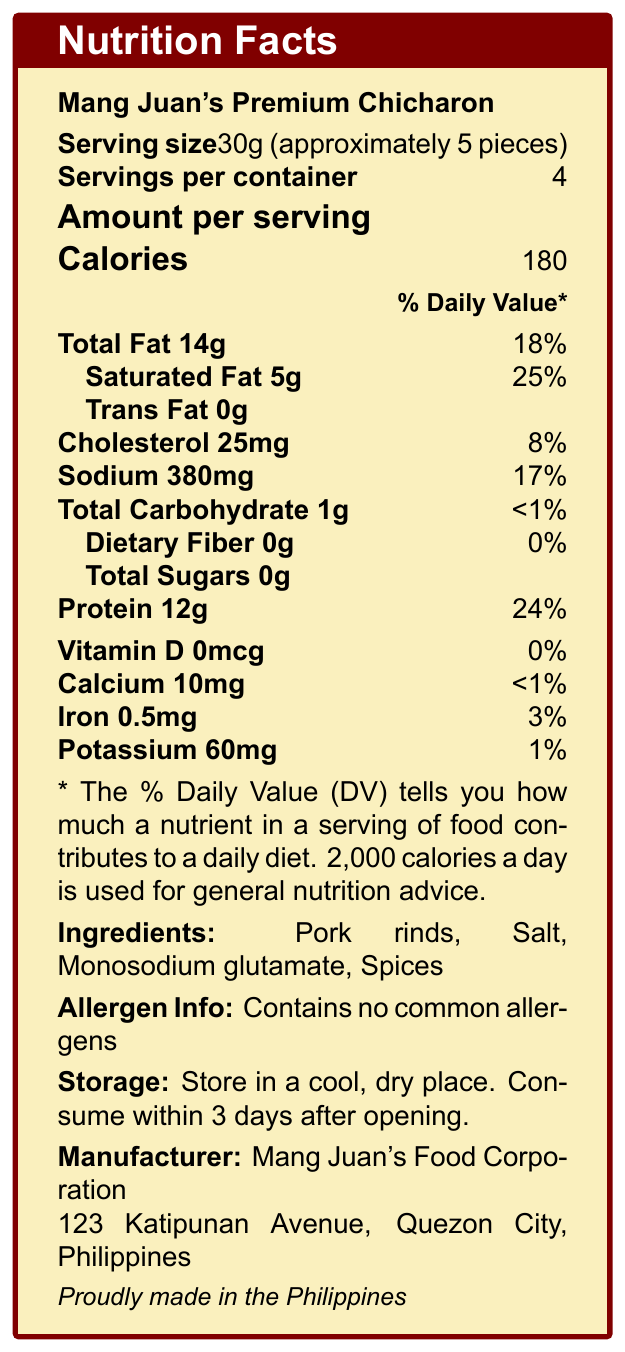what is the serving size of Mang Juan's Premium Chicharon? The serving size is specified in the document as 30g, which is approximately 5 pieces.
Answer: 30g (approximately 5 pieces) how many servings are there per container? The document states that the product has 4 servings per container.
Answer: 4 what is the amount of protein per serving? The amount of protein per serving is clearly indicated as 12g in the document.
Answer: 12g what percentage of the daily value of saturated fat does one serving contain? The document lists that one serving contains 25% of the daily value of saturated fat.
Answer: 25% what are the ingredients of Mang Juan's Premium Chicharon? The ingredients are listed in the document as Pork rinds, Salt, Monosodium glutamate, and Spices.
Answer: Pork rinds, Salt, Monosodium glutamate, Spices what is the total fat content per serving? According to the document, the total fat content per serving is 14g.
Answer: 14g how much sodium is in one serving? The document specifies that one serving contains 380mg of sodium.
Answer: 380mg how long should Mang Juan's Premium Chicharon be consumed after opening? The document advises consuming the product within 3 days after opening.
Answer: 3 days which of the following vitamins and minerals does Mang Juan's Premium Chicharon provide? A. Vitamin C B. Calcium C. Iron D. Vitamin D The document indicates that the product provides Iron (0.5mg), but Vitamin C, Calcium, and Vitamin D are either not provided or provided in very small amounts.
Answer: C. Iron what type of fat is minimally present in chicharon? A. Monounsaturated fat B. Trans fat C. Saturated fat D. Polyunsaturated fat The document highlights that the fat in chicharon has minimal trans fat.
Answer: B. Trans fat is the chicharon made in the Philippines? Yes/No The document states that the chicharon is proudly made in the Philippines.
Answer: Yes describe the key nutritional information found in the nutrition facts label for Mang Juan's Premium Chicharon. This summary provides a concise overview of the primary nutritional information for the product.
Answer: The nutrition facts label for Mang Juan's Premium Chicharon highlights that one serving size is 30g (approximately 5 pieces) and there are 4 servings per container. Each serving contains 180 calories, 14g of total fat (18% DV), 5g of saturated fat (25% DV), 0g of trans fat, 25mg of cholesterol (8% DV), 380mg of sodium (17% DV), 1g of total carbohydrate (<1% DV), 0g of dietary fiber (0% DV), 12g of protein (24% DV), and small amounts of calcium, iron, and potassium. what is the main source of protein in this chicharon? The explanation is found in the additional information section of the document.
Answer: The high protein content in chicharon comes from the collagen in pork skin, which is converted to gelatin during the cooking process. what are the cooking phenomena involved in the frying process of chicharon from a chemical engineering perspective? This detail is mentioned in the additional information section which relates to chemical engineering.
Answer: The frying process of chicharon involves complex heat and mass transfer phenomena, as well as protein denaturation and Maillard reactions for flavor development. what percentage daily value of dietary fiber does one serving of chicharon provide? The document shows that one serving contains 0g of dietary fiber, which equates to 0% of the daily value.
Answer: 0% what is the company address for the manufacturer? The document lists the manufacturer's address as 123 Katipunan Avenue, Quezon City, Philippines.
Answer: 123 Katipunan Avenue, Quezon City, Philippines does Mang Juan's Premium Chicharon contain any common allergens? The document explicitly mentions that this product contains no common allergens.
Answer: No list the types of fat present in Mang Juan's Premium Chicharon. The additional information in the document states that the fat in chicharon is primarily composed of monounsaturated and saturated fats, with minimal trans fats.
Answer: Monounsaturated fats, Saturated fats, minimal Trans fats describe the sustainability note mentioned in the document. The additional sustainability note section mentions that chicharon production helps in sustainability by using pork by-products.
Answer: The production of chicharon utilizes pork by-products, contributing to more sustainable meat processing practices. 